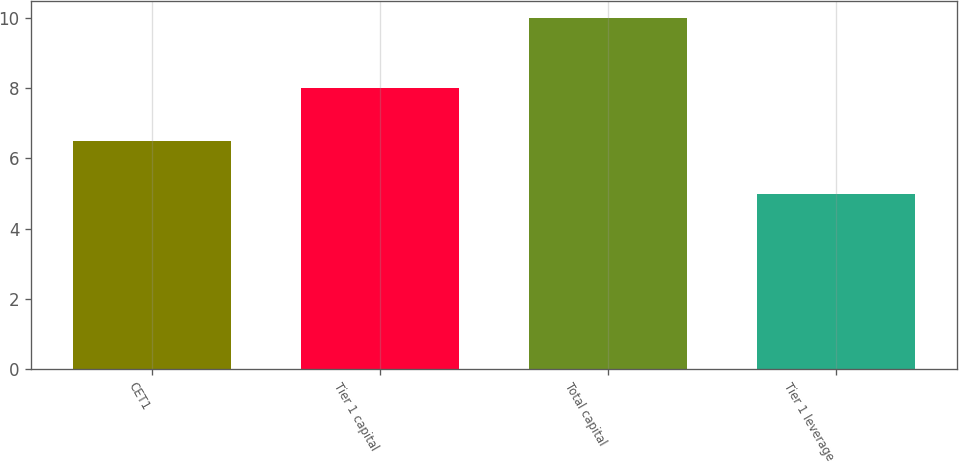Convert chart. <chart><loc_0><loc_0><loc_500><loc_500><bar_chart><fcel>CET1<fcel>Tier 1 capital<fcel>Total capital<fcel>Tier 1 leverage<nl><fcel>6.5<fcel>8<fcel>10<fcel>5<nl></chart> 